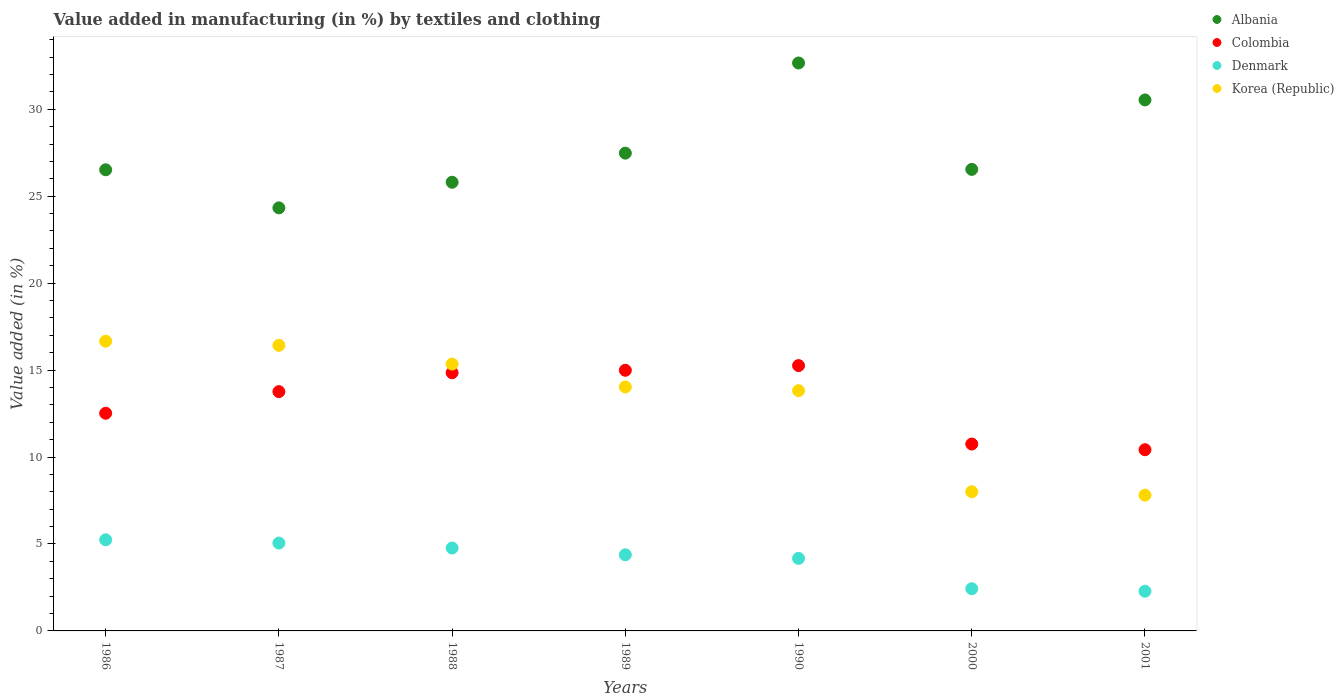How many different coloured dotlines are there?
Ensure brevity in your answer.  4. What is the percentage of value added in manufacturing by textiles and clothing in Korea (Republic) in 1990?
Provide a short and direct response. 13.82. Across all years, what is the maximum percentage of value added in manufacturing by textiles and clothing in Albania?
Your answer should be very brief. 32.66. Across all years, what is the minimum percentage of value added in manufacturing by textiles and clothing in Albania?
Ensure brevity in your answer.  24.33. In which year was the percentage of value added in manufacturing by textiles and clothing in Korea (Republic) minimum?
Make the answer very short. 2001. What is the total percentage of value added in manufacturing by textiles and clothing in Albania in the graph?
Provide a short and direct response. 193.86. What is the difference between the percentage of value added in manufacturing by textiles and clothing in Albania in 1990 and that in 2000?
Provide a short and direct response. 6.12. What is the difference between the percentage of value added in manufacturing by textiles and clothing in Denmark in 1989 and the percentage of value added in manufacturing by textiles and clothing in Albania in 1986?
Your answer should be very brief. -22.14. What is the average percentage of value added in manufacturing by textiles and clothing in Colombia per year?
Offer a terse response. 13.22. In the year 2001, what is the difference between the percentage of value added in manufacturing by textiles and clothing in Denmark and percentage of value added in manufacturing by textiles and clothing in Colombia?
Ensure brevity in your answer.  -8.14. What is the ratio of the percentage of value added in manufacturing by textiles and clothing in Denmark in 1987 to that in 1990?
Offer a very short reply. 1.21. Is the percentage of value added in manufacturing by textiles and clothing in Colombia in 1989 less than that in 2000?
Give a very brief answer. No. Is the difference between the percentage of value added in manufacturing by textiles and clothing in Denmark in 1990 and 2001 greater than the difference between the percentage of value added in manufacturing by textiles and clothing in Colombia in 1990 and 2001?
Keep it short and to the point. No. What is the difference between the highest and the second highest percentage of value added in manufacturing by textiles and clothing in Albania?
Keep it short and to the point. 2.12. What is the difference between the highest and the lowest percentage of value added in manufacturing by textiles and clothing in Denmark?
Your answer should be very brief. 2.96. In how many years, is the percentage of value added in manufacturing by textiles and clothing in Albania greater than the average percentage of value added in manufacturing by textiles and clothing in Albania taken over all years?
Your answer should be very brief. 2. Is it the case that in every year, the sum of the percentage of value added in manufacturing by textiles and clothing in Colombia and percentage of value added in manufacturing by textiles and clothing in Korea (Republic)  is greater than the sum of percentage of value added in manufacturing by textiles and clothing in Denmark and percentage of value added in manufacturing by textiles and clothing in Albania?
Keep it short and to the point. No. Does the percentage of value added in manufacturing by textiles and clothing in Albania monotonically increase over the years?
Provide a succinct answer. No. Is the percentage of value added in manufacturing by textiles and clothing in Albania strictly greater than the percentage of value added in manufacturing by textiles and clothing in Denmark over the years?
Provide a short and direct response. Yes. Is the percentage of value added in manufacturing by textiles and clothing in Colombia strictly less than the percentage of value added in manufacturing by textiles and clothing in Korea (Republic) over the years?
Provide a succinct answer. No. How many dotlines are there?
Give a very brief answer. 4. Does the graph contain any zero values?
Provide a succinct answer. No. Does the graph contain grids?
Ensure brevity in your answer.  No. How are the legend labels stacked?
Your answer should be compact. Vertical. What is the title of the graph?
Provide a succinct answer. Value added in manufacturing (in %) by textiles and clothing. What is the label or title of the Y-axis?
Your response must be concise. Value added (in %). What is the Value added (in %) of Albania in 1986?
Your answer should be compact. 26.52. What is the Value added (in %) in Colombia in 1986?
Provide a succinct answer. 12.52. What is the Value added (in %) of Denmark in 1986?
Make the answer very short. 5.24. What is the Value added (in %) in Korea (Republic) in 1986?
Your answer should be compact. 16.66. What is the Value added (in %) in Albania in 1987?
Provide a succinct answer. 24.33. What is the Value added (in %) in Colombia in 1987?
Offer a very short reply. 13.76. What is the Value added (in %) of Denmark in 1987?
Make the answer very short. 5.05. What is the Value added (in %) in Korea (Republic) in 1987?
Your answer should be compact. 16.42. What is the Value added (in %) of Albania in 1988?
Your answer should be very brief. 25.8. What is the Value added (in %) in Colombia in 1988?
Your response must be concise. 14.85. What is the Value added (in %) in Denmark in 1988?
Offer a terse response. 4.77. What is the Value added (in %) of Korea (Republic) in 1988?
Your response must be concise. 15.35. What is the Value added (in %) in Albania in 1989?
Your answer should be very brief. 27.47. What is the Value added (in %) in Colombia in 1989?
Your answer should be compact. 14.99. What is the Value added (in %) of Denmark in 1989?
Give a very brief answer. 4.38. What is the Value added (in %) in Korea (Republic) in 1989?
Your answer should be very brief. 14.03. What is the Value added (in %) of Albania in 1990?
Ensure brevity in your answer.  32.66. What is the Value added (in %) in Colombia in 1990?
Your answer should be compact. 15.26. What is the Value added (in %) of Denmark in 1990?
Make the answer very short. 4.17. What is the Value added (in %) of Korea (Republic) in 1990?
Offer a very short reply. 13.82. What is the Value added (in %) of Albania in 2000?
Ensure brevity in your answer.  26.54. What is the Value added (in %) of Colombia in 2000?
Offer a terse response. 10.75. What is the Value added (in %) of Denmark in 2000?
Keep it short and to the point. 2.43. What is the Value added (in %) in Korea (Republic) in 2000?
Make the answer very short. 8. What is the Value added (in %) of Albania in 2001?
Provide a succinct answer. 30.53. What is the Value added (in %) of Colombia in 2001?
Your answer should be compact. 10.42. What is the Value added (in %) in Denmark in 2001?
Ensure brevity in your answer.  2.28. What is the Value added (in %) in Korea (Republic) in 2001?
Your answer should be very brief. 7.81. Across all years, what is the maximum Value added (in %) in Albania?
Keep it short and to the point. 32.66. Across all years, what is the maximum Value added (in %) of Colombia?
Give a very brief answer. 15.26. Across all years, what is the maximum Value added (in %) of Denmark?
Ensure brevity in your answer.  5.24. Across all years, what is the maximum Value added (in %) in Korea (Republic)?
Your answer should be very brief. 16.66. Across all years, what is the minimum Value added (in %) of Albania?
Ensure brevity in your answer.  24.33. Across all years, what is the minimum Value added (in %) of Colombia?
Make the answer very short. 10.42. Across all years, what is the minimum Value added (in %) in Denmark?
Make the answer very short. 2.28. Across all years, what is the minimum Value added (in %) in Korea (Republic)?
Keep it short and to the point. 7.81. What is the total Value added (in %) of Albania in the graph?
Your response must be concise. 193.86. What is the total Value added (in %) of Colombia in the graph?
Ensure brevity in your answer.  92.54. What is the total Value added (in %) of Denmark in the graph?
Provide a succinct answer. 28.32. What is the total Value added (in %) in Korea (Republic) in the graph?
Give a very brief answer. 92.08. What is the difference between the Value added (in %) of Albania in 1986 and that in 1987?
Make the answer very short. 2.19. What is the difference between the Value added (in %) in Colombia in 1986 and that in 1987?
Offer a terse response. -1.24. What is the difference between the Value added (in %) of Denmark in 1986 and that in 1987?
Provide a succinct answer. 0.19. What is the difference between the Value added (in %) in Korea (Republic) in 1986 and that in 1987?
Provide a short and direct response. 0.24. What is the difference between the Value added (in %) of Albania in 1986 and that in 1988?
Offer a very short reply. 0.72. What is the difference between the Value added (in %) in Colombia in 1986 and that in 1988?
Make the answer very short. -2.33. What is the difference between the Value added (in %) in Denmark in 1986 and that in 1988?
Provide a succinct answer. 0.47. What is the difference between the Value added (in %) in Korea (Republic) in 1986 and that in 1988?
Make the answer very short. 1.31. What is the difference between the Value added (in %) in Albania in 1986 and that in 1989?
Your answer should be compact. -0.96. What is the difference between the Value added (in %) of Colombia in 1986 and that in 1989?
Your answer should be compact. -2.47. What is the difference between the Value added (in %) in Denmark in 1986 and that in 1989?
Provide a succinct answer. 0.86. What is the difference between the Value added (in %) of Korea (Republic) in 1986 and that in 1989?
Give a very brief answer. 2.63. What is the difference between the Value added (in %) of Albania in 1986 and that in 1990?
Ensure brevity in your answer.  -6.14. What is the difference between the Value added (in %) in Colombia in 1986 and that in 1990?
Keep it short and to the point. -2.74. What is the difference between the Value added (in %) in Denmark in 1986 and that in 1990?
Your response must be concise. 1.07. What is the difference between the Value added (in %) of Korea (Republic) in 1986 and that in 1990?
Keep it short and to the point. 2.84. What is the difference between the Value added (in %) in Albania in 1986 and that in 2000?
Keep it short and to the point. -0.02. What is the difference between the Value added (in %) in Colombia in 1986 and that in 2000?
Offer a terse response. 1.77. What is the difference between the Value added (in %) of Denmark in 1986 and that in 2000?
Provide a short and direct response. 2.81. What is the difference between the Value added (in %) of Korea (Republic) in 1986 and that in 2000?
Your answer should be very brief. 8.66. What is the difference between the Value added (in %) of Albania in 1986 and that in 2001?
Give a very brief answer. -4.02. What is the difference between the Value added (in %) of Colombia in 1986 and that in 2001?
Ensure brevity in your answer.  2.1. What is the difference between the Value added (in %) in Denmark in 1986 and that in 2001?
Keep it short and to the point. 2.96. What is the difference between the Value added (in %) of Korea (Republic) in 1986 and that in 2001?
Keep it short and to the point. 8.85. What is the difference between the Value added (in %) in Albania in 1987 and that in 1988?
Provide a succinct answer. -1.47. What is the difference between the Value added (in %) in Colombia in 1987 and that in 1988?
Keep it short and to the point. -1.09. What is the difference between the Value added (in %) in Denmark in 1987 and that in 1988?
Give a very brief answer. 0.28. What is the difference between the Value added (in %) in Korea (Republic) in 1987 and that in 1988?
Your answer should be very brief. 1.08. What is the difference between the Value added (in %) of Albania in 1987 and that in 1989?
Provide a succinct answer. -3.15. What is the difference between the Value added (in %) of Colombia in 1987 and that in 1989?
Offer a very short reply. -1.23. What is the difference between the Value added (in %) of Denmark in 1987 and that in 1989?
Give a very brief answer. 0.68. What is the difference between the Value added (in %) of Korea (Republic) in 1987 and that in 1989?
Provide a succinct answer. 2.39. What is the difference between the Value added (in %) of Albania in 1987 and that in 1990?
Offer a terse response. -8.33. What is the difference between the Value added (in %) of Colombia in 1987 and that in 1990?
Provide a succinct answer. -1.5. What is the difference between the Value added (in %) of Denmark in 1987 and that in 1990?
Provide a short and direct response. 0.88. What is the difference between the Value added (in %) in Korea (Republic) in 1987 and that in 1990?
Provide a short and direct response. 2.61. What is the difference between the Value added (in %) of Albania in 1987 and that in 2000?
Your response must be concise. -2.21. What is the difference between the Value added (in %) in Colombia in 1987 and that in 2000?
Your answer should be very brief. 3.01. What is the difference between the Value added (in %) of Denmark in 1987 and that in 2000?
Your response must be concise. 2.62. What is the difference between the Value added (in %) in Korea (Republic) in 1987 and that in 2000?
Give a very brief answer. 8.42. What is the difference between the Value added (in %) of Albania in 1987 and that in 2001?
Your answer should be very brief. -6.21. What is the difference between the Value added (in %) of Colombia in 1987 and that in 2001?
Provide a succinct answer. 3.34. What is the difference between the Value added (in %) in Denmark in 1987 and that in 2001?
Provide a short and direct response. 2.77. What is the difference between the Value added (in %) in Korea (Republic) in 1987 and that in 2001?
Ensure brevity in your answer.  8.61. What is the difference between the Value added (in %) in Albania in 1988 and that in 1989?
Offer a very short reply. -1.67. What is the difference between the Value added (in %) in Colombia in 1988 and that in 1989?
Offer a terse response. -0.14. What is the difference between the Value added (in %) of Denmark in 1988 and that in 1989?
Keep it short and to the point. 0.39. What is the difference between the Value added (in %) of Korea (Republic) in 1988 and that in 1989?
Your answer should be compact. 1.32. What is the difference between the Value added (in %) in Albania in 1988 and that in 1990?
Your answer should be compact. -6.86. What is the difference between the Value added (in %) in Colombia in 1988 and that in 1990?
Make the answer very short. -0.41. What is the difference between the Value added (in %) of Denmark in 1988 and that in 1990?
Provide a short and direct response. 0.6. What is the difference between the Value added (in %) in Korea (Republic) in 1988 and that in 1990?
Ensure brevity in your answer.  1.53. What is the difference between the Value added (in %) of Albania in 1988 and that in 2000?
Make the answer very short. -0.74. What is the difference between the Value added (in %) in Colombia in 1988 and that in 2000?
Provide a short and direct response. 4.1. What is the difference between the Value added (in %) in Denmark in 1988 and that in 2000?
Your answer should be very brief. 2.34. What is the difference between the Value added (in %) of Korea (Republic) in 1988 and that in 2000?
Provide a succinct answer. 7.34. What is the difference between the Value added (in %) of Albania in 1988 and that in 2001?
Give a very brief answer. -4.73. What is the difference between the Value added (in %) of Colombia in 1988 and that in 2001?
Your answer should be compact. 4.43. What is the difference between the Value added (in %) of Denmark in 1988 and that in 2001?
Give a very brief answer. 2.49. What is the difference between the Value added (in %) of Korea (Republic) in 1988 and that in 2001?
Provide a short and direct response. 7.54. What is the difference between the Value added (in %) of Albania in 1989 and that in 1990?
Make the answer very short. -5.18. What is the difference between the Value added (in %) of Colombia in 1989 and that in 1990?
Keep it short and to the point. -0.27. What is the difference between the Value added (in %) of Denmark in 1989 and that in 1990?
Your answer should be compact. 0.21. What is the difference between the Value added (in %) in Korea (Republic) in 1989 and that in 1990?
Offer a very short reply. 0.21. What is the difference between the Value added (in %) in Albania in 1989 and that in 2000?
Offer a very short reply. 0.93. What is the difference between the Value added (in %) of Colombia in 1989 and that in 2000?
Give a very brief answer. 4.24. What is the difference between the Value added (in %) in Denmark in 1989 and that in 2000?
Ensure brevity in your answer.  1.95. What is the difference between the Value added (in %) in Korea (Republic) in 1989 and that in 2000?
Provide a succinct answer. 6.03. What is the difference between the Value added (in %) in Albania in 1989 and that in 2001?
Your response must be concise. -3.06. What is the difference between the Value added (in %) in Colombia in 1989 and that in 2001?
Your answer should be compact. 4.57. What is the difference between the Value added (in %) in Denmark in 1989 and that in 2001?
Your response must be concise. 2.09. What is the difference between the Value added (in %) in Korea (Republic) in 1989 and that in 2001?
Your answer should be compact. 6.22. What is the difference between the Value added (in %) of Albania in 1990 and that in 2000?
Your response must be concise. 6.12. What is the difference between the Value added (in %) in Colombia in 1990 and that in 2000?
Offer a very short reply. 4.51. What is the difference between the Value added (in %) in Denmark in 1990 and that in 2000?
Keep it short and to the point. 1.74. What is the difference between the Value added (in %) of Korea (Republic) in 1990 and that in 2000?
Make the answer very short. 5.81. What is the difference between the Value added (in %) in Albania in 1990 and that in 2001?
Your answer should be compact. 2.12. What is the difference between the Value added (in %) of Colombia in 1990 and that in 2001?
Provide a short and direct response. 4.84. What is the difference between the Value added (in %) of Denmark in 1990 and that in 2001?
Provide a short and direct response. 1.89. What is the difference between the Value added (in %) in Korea (Republic) in 1990 and that in 2001?
Your answer should be very brief. 6.01. What is the difference between the Value added (in %) in Albania in 2000 and that in 2001?
Provide a succinct answer. -3.99. What is the difference between the Value added (in %) in Colombia in 2000 and that in 2001?
Your answer should be very brief. 0.33. What is the difference between the Value added (in %) of Denmark in 2000 and that in 2001?
Offer a terse response. 0.15. What is the difference between the Value added (in %) of Korea (Republic) in 2000 and that in 2001?
Make the answer very short. 0.2. What is the difference between the Value added (in %) of Albania in 1986 and the Value added (in %) of Colombia in 1987?
Offer a terse response. 12.76. What is the difference between the Value added (in %) of Albania in 1986 and the Value added (in %) of Denmark in 1987?
Your answer should be very brief. 21.47. What is the difference between the Value added (in %) of Albania in 1986 and the Value added (in %) of Korea (Republic) in 1987?
Make the answer very short. 10.1. What is the difference between the Value added (in %) of Colombia in 1986 and the Value added (in %) of Denmark in 1987?
Ensure brevity in your answer.  7.46. What is the difference between the Value added (in %) of Colombia in 1986 and the Value added (in %) of Korea (Republic) in 1987?
Your response must be concise. -3.9. What is the difference between the Value added (in %) in Denmark in 1986 and the Value added (in %) in Korea (Republic) in 1987?
Keep it short and to the point. -11.18. What is the difference between the Value added (in %) in Albania in 1986 and the Value added (in %) in Colombia in 1988?
Provide a short and direct response. 11.67. What is the difference between the Value added (in %) of Albania in 1986 and the Value added (in %) of Denmark in 1988?
Make the answer very short. 21.75. What is the difference between the Value added (in %) in Albania in 1986 and the Value added (in %) in Korea (Republic) in 1988?
Ensure brevity in your answer.  11.17. What is the difference between the Value added (in %) of Colombia in 1986 and the Value added (in %) of Denmark in 1988?
Provide a short and direct response. 7.75. What is the difference between the Value added (in %) in Colombia in 1986 and the Value added (in %) in Korea (Republic) in 1988?
Make the answer very short. -2.83. What is the difference between the Value added (in %) in Denmark in 1986 and the Value added (in %) in Korea (Republic) in 1988?
Keep it short and to the point. -10.11. What is the difference between the Value added (in %) of Albania in 1986 and the Value added (in %) of Colombia in 1989?
Give a very brief answer. 11.53. What is the difference between the Value added (in %) of Albania in 1986 and the Value added (in %) of Denmark in 1989?
Provide a short and direct response. 22.14. What is the difference between the Value added (in %) of Albania in 1986 and the Value added (in %) of Korea (Republic) in 1989?
Provide a succinct answer. 12.49. What is the difference between the Value added (in %) of Colombia in 1986 and the Value added (in %) of Denmark in 1989?
Provide a short and direct response. 8.14. What is the difference between the Value added (in %) of Colombia in 1986 and the Value added (in %) of Korea (Republic) in 1989?
Your answer should be compact. -1.51. What is the difference between the Value added (in %) in Denmark in 1986 and the Value added (in %) in Korea (Republic) in 1989?
Make the answer very short. -8.79. What is the difference between the Value added (in %) of Albania in 1986 and the Value added (in %) of Colombia in 1990?
Your response must be concise. 11.26. What is the difference between the Value added (in %) in Albania in 1986 and the Value added (in %) in Denmark in 1990?
Give a very brief answer. 22.35. What is the difference between the Value added (in %) in Albania in 1986 and the Value added (in %) in Korea (Republic) in 1990?
Make the answer very short. 12.7. What is the difference between the Value added (in %) of Colombia in 1986 and the Value added (in %) of Denmark in 1990?
Ensure brevity in your answer.  8.35. What is the difference between the Value added (in %) in Colombia in 1986 and the Value added (in %) in Korea (Republic) in 1990?
Your answer should be compact. -1.3. What is the difference between the Value added (in %) of Denmark in 1986 and the Value added (in %) of Korea (Republic) in 1990?
Offer a terse response. -8.58. What is the difference between the Value added (in %) in Albania in 1986 and the Value added (in %) in Colombia in 2000?
Provide a succinct answer. 15.77. What is the difference between the Value added (in %) of Albania in 1986 and the Value added (in %) of Denmark in 2000?
Offer a terse response. 24.09. What is the difference between the Value added (in %) of Albania in 1986 and the Value added (in %) of Korea (Republic) in 2000?
Give a very brief answer. 18.51. What is the difference between the Value added (in %) of Colombia in 1986 and the Value added (in %) of Denmark in 2000?
Provide a succinct answer. 10.09. What is the difference between the Value added (in %) in Colombia in 1986 and the Value added (in %) in Korea (Republic) in 2000?
Provide a succinct answer. 4.51. What is the difference between the Value added (in %) in Denmark in 1986 and the Value added (in %) in Korea (Republic) in 2000?
Your response must be concise. -2.76. What is the difference between the Value added (in %) of Albania in 1986 and the Value added (in %) of Colombia in 2001?
Provide a succinct answer. 16.1. What is the difference between the Value added (in %) in Albania in 1986 and the Value added (in %) in Denmark in 2001?
Your answer should be compact. 24.24. What is the difference between the Value added (in %) in Albania in 1986 and the Value added (in %) in Korea (Republic) in 2001?
Provide a succinct answer. 18.71. What is the difference between the Value added (in %) of Colombia in 1986 and the Value added (in %) of Denmark in 2001?
Give a very brief answer. 10.23. What is the difference between the Value added (in %) in Colombia in 1986 and the Value added (in %) in Korea (Republic) in 2001?
Provide a short and direct response. 4.71. What is the difference between the Value added (in %) of Denmark in 1986 and the Value added (in %) of Korea (Republic) in 2001?
Give a very brief answer. -2.57. What is the difference between the Value added (in %) of Albania in 1987 and the Value added (in %) of Colombia in 1988?
Give a very brief answer. 9.48. What is the difference between the Value added (in %) in Albania in 1987 and the Value added (in %) in Denmark in 1988?
Your response must be concise. 19.56. What is the difference between the Value added (in %) of Albania in 1987 and the Value added (in %) of Korea (Republic) in 1988?
Provide a short and direct response. 8.98. What is the difference between the Value added (in %) of Colombia in 1987 and the Value added (in %) of Denmark in 1988?
Keep it short and to the point. 8.99. What is the difference between the Value added (in %) of Colombia in 1987 and the Value added (in %) of Korea (Republic) in 1988?
Provide a short and direct response. -1.59. What is the difference between the Value added (in %) in Denmark in 1987 and the Value added (in %) in Korea (Republic) in 1988?
Keep it short and to the point. -10.29. What is the difference between the Value added (in %) of Albania in 1987 and the Value added (in %) of Colombia in 1989?
Ensure brevity in your answer.  9.34. What is the difference between the Value added (in %) of Albania in 1987 and the Value added (in %) of Denmark in 1989?
Provide a short and direct response. 19.95. What is the difference between the Value added (in %) in Albania in 1987 and the Value added (in %) in Korea (Republic) in 1989?
Your response must be concise. 10.3. What is the difference between the Value added (in %) of Colombia in 1987 and the Value added (in %) of Denmark in 1989?
Make the answer very short. 9.38. What is the difference between the Value added (in %) in Colombia in 1987 and the Value added (in %) in Korea (Republic) in 1989?
Ensure brevity in your answer.  -0.27. What is the difference between the Value added (in %) of Denmark in 1987 and the Value added (in %) of Korea (Republic) in 1989?
Provide a short and direct response. -8.98. What is the difference between the Value added (in %) in Albania in 1987 and the Value added (in %) in Colombia in 1990?
Your answer should be compact. 9.07. What is the difference between the Value added (in %) of Albania in 1987 and the Value added (in %) of Denmark in 1990?
Keep it short and to the point. 20.16. What is the difference between the Value added (in %) of Albania in 1987 and the Value added (in %) of Korea (Republic) in 1990?
Give a very brief answer. 10.51. What is the difference between the Value added (in %) in Colombia in 1987 and the Value added (in %) in Denmark in 1990?
Make the answer very short. 9.59. What is the difference between the Value added (in %) in Colombia in 1987 and the Value added (in %) in Korea (Republic) in 1990?
Keep it short and to the point. -0.06. What is the difference between the Value added (in %) of Denmark in 1987 and the Value added (in %) of Korea (Republic) in 1990?
Make the answer very short. -8.76. What is the difference between the Value added (in %) in Albania in 1987 and the Value added (in %) in Colombia in 2000?
Give a very brief answer. 13.58. What is the difference between the Value added (in %) in Albania in 1987 and the Value added (in %) in Denmark in 2000?
Ensure brevity in your answer.  21.9. What is the difference between the Value added (in %) of Albania in 1987 and the Value added (in %) of Korea (Republic) in 2000?
Your answer should be very brief. 16.33. What is the difference between the Value added (in %) in Colombia in 1987 and the Value added (in %) in Denmark in 2000?
Provide a succinct answer. 11.33. What is the difference between the Value added (in %) in Colombia in 1987 and the Value added (in %) in Korea (Republic) in 2000?
Keep it short and to the point. 5.76. What is the difference between the Value added (in %) of Denmark in 1987 and the Value added (in %) of Korea (Republic) in 2000?
Offer a very short reply. -2.95. What is the difference between the Value added (in %) in Albania in 1987 and the Value added (in %) in Colombia in 2001?
Give a very brief answer. 13.91. What is the difference between the Value added (in %) of Albania in 1987 and the Value added (in %) of Denmark in 2001?
Your response must be concise. 22.05. What is the difference between the Value added (in %) in Albania in 1987 and the Value added (in %) in Korea (Republic) in 2001?
Offer a very short reply. 16.52. What is the difference between the Value added (in %) in Colombia in 1987 and the Value added (in %) in Denmark in 2001?
Provide a succinct answer. 11.48. What is the difference between the Value added (in %) of Colombia in 1987 and the Value added (in %) of Korea (Republic) in 2001?
Provide a short and direct response. 5.95. What is the difference between the Value added (in %) in Denmark in 1987 and the Value added (in %) in Korea (Republic) in 2001?
Make the answer very short. -2.76. What is the difference between the Value added (in %) of Albania in 1988 and the Value added (in %) of Colombia in 1989?
Provide a short and direct response. 10.81. What is the difference between the Value added (in %) of Albania in 1988 and the Value added (in %) of Denmark in 1989?
Provide a short and direct response. 21.42. What is the difference between the Value added (in %) of Albania in 1988 and the Value added (in %) of Korea (Republic) in 1989?
Your answer should be very brief. 11.77. What is the difference between the Value added (in %) of Colombia in 1988 and the Value added (in %) of Denmark in 1989?
Ensure brevity in your answer.  10.47. What is the difference between the Value added (in %) in Colombia in 1988 and the Value added (in %) in Korea (Republic) in 1989?
Offer a very short reply. 0.82. What is the difference between the Value added (in %) of Denmark in 1988 and the Value added (in %) of Korea (Republic) in 1989?
Provide a succinct answer. -9.26. What is the difference between the Value added (in %) in Albania in 1988 and the Value added (in %) in Colombia in 1990?
Your answer should be compact. 10.54. What is the difference between the Value added (in %) in Albania in 1988 and the Value added (in %) in Denmark in 1990?
Your response must be concise. 21.63. What is the difference between the Value added (in %) of Albania in 1988 and the Value added (in %) of Korea (Republic) in 1990?
Keep it short and to the point. 11.99. What is the difference between the Value added (in %) of Colombia in 1988 and the Value added (in %) of Denmark in 1990?
Your answer should be compact. 10.68. What is the difference between the Value added (in %) of Colombia in 1988 and the Value added (in %) of Korea (Republic) in 1990?
Your response must be concise. 1.03. What is the difference between the Value added (in %) in Denmark in 1988 and the Value added (in %) in Korea (Republic) in 1990?
Your answer should be very brief. -9.05. What is the difference between the Value added (in %) in Albania in 1988 and the Value added (in %) in Colombia in 2000?
Your answer should be very brief. 15.05. What is the difference between the Value added (in %) in Albania in 1988 and the Value added (in %) in Denmark in 2000?
Your answer should be compact. 23.37. What is the difference between the Value added (in %) in Albania in 1988 and the Value added (in %) in Korea (Republic) in 2000?
Offer a very short reply. 17.8. What is the difference between the Value added (in %) of Colombia in 1988 and the Value added (in %) of Denmark in 2000?
Provide a succinct answer. 12.42. What is the difference between the Value added (in %) in Colombia in 1988 and the Value added (in %) in Korea (Republic) in 2000?
Provide a succinct answer. 6.84. What is the difference between the Value added (in %) of Denmark in 1988 and the Value added (in %) of Korea (Republic) in 2000?
Make the answer very short. -3.24. What is the difference between the Value added (in %) of Albania in 1988 and the Value added (in %) of Colombia in 2001?
Make the answer very short. 15.38. What is the difference between the Value added (in %) of Albania in 1988 and the Value added (in %) of Denmark in 2001?
Offer a terse response. 23.52. What is the difference between the Value added (in %) in Albania in 1988 and the Value added (in %) in Korea (Republic) in 2001?
Your answer should be very brief. 17.99. What is the difference between the Value added (in %) of Colombia in 1988 and the Value added (in %) of Denmark in 2001?
Your answer should be very brief. 12.56. What is the difference between the Value added (in %) of Colombia in 1988 and the Value added (in %) of Korea (Republic) in 2001?
Your response must be concise. 7.04. What is the difference between the Value added (in %) in Denmark in 1988 and the Value added (in %) in Korea (Republic) in 2001?
Ensure brevity in your answer.  -3.04. What is the difference between the Value added (in %) in Albania in 1989 and the Value added (in %) in Colombia in 1990?
Offer a very short reply. 12.22. What is the difference between the Value added (in %) in Albania in 1989 and the Value added (in %) in Denmark in 1990?
Make the answer very short. 23.3. What is the difference between the Value added (in %) in Albania in 1989 and the Value added (in %) in Korea (Republic) in 1990?
Your answer should be very brief. 13.66. What is the difference between the Value added (in %) in Colombia in 1989 and the Value added (in %) in Denmark in 1990?
Keep it short and to the point. 10.82. What is the difference between the Value added (in %) of Colombia in 1989 and the Value added (in %) of Korea (Republic) in 1990?
Make the answer very short. 1.17. What is the difference between the Value added (in %) in Denmark in 1989 and the Value added (in %) in Korea (Republic) in 1990?
Provide a succinct answer. -9.44. What is the difference between the Value added (in %) in Albania in 1989 and the Value added (in %) in Colombia in 2000?
Provide a succinct answer. 16.73. What is the difference between the Value added (in %) in Albania in 1989 and the Value added (in %) in Denmark in 2000?
Provide a short and direct response. 25.05. What is the difference between the Value added (in %) of Albania in 1989 and the Value added (in %) of Korea (Republic) in 2000?
Offer a terse response. 19.47. What is the difference between the Value added (in %) in Colombia in 1989 and the Value added (in %) in Denmark in 2000?
Your answer should be very brief. 12.56. What is the difference between the Value added (in %) of Colombia in 1989 and the Value added (in %) of Korea (Republic) in 2000?
Give a very brief answer. 6.98. What is the difference between the Value added (in %) of Denmark in 1989 and the Value added (in %) of Korea (Republic) in 2000?
Your answer should be very brief. -3.63. What is the difference between the Value added (in %) of Albania in 1989 and the Value added (in %) of Colombia in 2001?
Give a very brief answer. 17.05. What is the difference between the Value added (in %) in Albania in 1989 and the Value added (in %) in Denmark in 2001?
Provide a short and direct response. 25.19. What is the difference between the Value added (in %) in Albania in 1989 and the Value added (in %) in Korea (Republic) in 2001?
Your answer should be very brief. 19.67. What is the difference between the Value added (in %) of Colombia in 1989 and the Value added (in %) of Denmark in 2001?
Offer a very short reply. 12.71. What is the difference between the Value added (in %) of Colombia in 1989 and the Value added (in %) of Korea (Republic) in 2001?
Ensure brevity in your answer.  7.18. What is the difference between the Value added (in %) of Denmark in 1989 and the Value added (in %) of Korea (Republic) in 2001?
Offer a terse response. -3.43. What is the difference between the Value added (in %) in Albania in 1990 and the Value added (in %) in Colombia in 2000?
Give a very brief answer. 21.91. What is the difference between the Value added (in %) of Albania in 1990 and the Value added (in %) of Denmark in 2000?
Provide a short and direct response. 30.23. What is the difference between the Value added (in %) of Albania in 1990 and the Value added (in %) of Korea (Republic) in 2000?
Make the answer very short. 24.66. What is the difference between the Value added (in %) in Colombia in 1990 and the Value added (in %) in Denmark in 2000?
Your response must be concise. 12.83. What is the difference between the Value added (in %) in Colombia in 1990 and the Value added (in %) in Korea (Republic) in 2000?
Your answer should be compact. 7.25. What is the difference between the Value added (in %) in Denmark in 1990 and the Value added (in %) in Korea (Republic) in 2000?
Ensure brevity in your answer.  -3.83. What is the difference between the Value added (in %) of Albania in 1990 and the Value added (in %) of Colombia in 2001?
Offer a very short reply. 22.24. What is the difference between the Value added (in %) of Albania in 1990 and the Value added (in %) of Denmark in 2001?
Ensure brevity in your answer.  30.38. What is the difference between the Value added (in %) in Albania in 1990 and the Value added (in %) in Korea (Republic) in 2001?
Your answer should be very brief. 24.85. What is the difference between the Value added (in %) in Colombia in 1990 and the Value added (in %) in Denmark in 2001?
Provide a succinct answer. 12.98. What is the difference between the Value added (in %) in Colombia in 1990 and the Value added (in %) in Korea (Republic) in 2001?
Provide a succinct answer. 7.45. What is the difference between the Value added (in %) in Denmark in 1990 and the Value added (in %) in Korea (Republic) in 2001?
Your answer should be compact. -3.64. What is the difference between the Value added (in %) in Albania in 2000 and the Value added (in %) in Colombia in 2001?
Your response must be concise. 16.12. What is the difference between the Value added (in %) of Albania in 2000 and the Value added (in %) of Denmark in 2001?
Your response must be concise. 24.26. What is the difference between the Value added (in %) of Albania in 2000 and the Value added (in %) of Korea (Republic) in 2001?
Provide a short and direct response. 18.73. What is the difference between the Value added (in %) of Colombia in 2000 and the Value added (in %) of Denmark in 2001?
Provide a short and direct response. 8.46. What is the difference between the Value added (in %) in Colombia in 2000 and the Value added (in %) in Korea (Republic) in 2001?
Provide a short and direct response. 2.94. What is the difference between the Value added (in %) of Denmark in 2000 and the Value added (in %) of Korea (Republic) in 2001?
Your response must be concise. -5.38. What is the average Value added (in %) in Albania per year?
Make the answer very short. 27.69. What is the average Value added (in %) in Colombia per year?
Provide a succinct answer. 13.22. What is the average Value added (in %) of Denmark per year?
Your answer should be very brief. 4.05. What is the average Value added (in %) in Korea (Republic) per year?
Give a very brief answer. 13.15. In the year 1986, what is the difference between the Value added (in %) of Albania and Value added (in %) of Colombia?
Offer a terse response. 14. In the year 1986, what is the difference between the Value added (in %) in Albania and Value added (in %) in Denmark?
Provide a short and direct response. 21.28. In the year 1986, what is the difference between the Value added (in %) in Albania and Value added (in %) in Korea (Republic)?
Offer a terse response. 9.86. In the year 1986, what is the difference between the Value added (in %) in Colombia and Value added (in %) in Denmark?
Give a very brief answer. 7.28. In the year 1986, what is the difference between the Value added (in %) in Colombia and Value added (in %) in Korea (Republic)?
Offer a very short reply. -4.14. In the year 1986, what is the difference between the Value added (in %) in Denmark and Value added (in %) in Korea (Republic)?
Give a very brief answer. -11.42. In the year 1987, what is the difference between the Value added (in %) of Albania and Value added (in %) of Colombia?
Your answer should be compact. 10.57. In the year 1987, what is the difference between the Value added (in %) of Albania and Value added (in %) of Denmark?
Your answer should be compact. 19.28. In the year 1987, what is the difference between the Value added (in %) of Albania and Value added (in %) of Korea (Republic)?
Offer a terse response. 7.91. In the year 1987, what is the difference between the Value added (in %) in Colombia and Value added (in %) in Denmark?
Provide a succinct answer. 8.71. In the year 1987, what is the difference between the Value added (in %) in Colombia and Value added (in %) in Korea (Republic)?
Your answer should be very brief. -2.66. In the year 1987, what is the difference between the Value added (in %) of Denmark and Value added (in %) of Korea (Republic)?
Your answer should be very brief. -11.37. In the year 1988, what is the difference between the Value added (in %) of Albania and Value added (in %) of Colombia?
Ensure brevity in your answer.  10.95. In the year 1988, what is the difference between the Value added (in %) of Albania and Value added (in %) of Denmark?
Offer a very short reply. 21.03. In the year 1988, what is the difference between the Value added (in %) in Albania and Value added (in %) in Korea (Republic)?
Keep it short and to the point. 10.46. In the year 1988, what is the difference between the Value added (in %) of Colombia and Value added (in %) of Denmark?
Keep it short and to the point. 10.08. In the year 1988, what is the difference between the Value added (in %) of Colombia and Value added (in %) of Korea (Republic)?
Your response must be concise. -0.5. In the year 1988, what is the difference between the Value added (in %) of Denmark and Value added (in %) of Korea (Republic)?
Your answer should be very brief. -10.58. In the year 1989, what is the difference between the Value added (in %) of Albania and Value added (in %) of Colombia?
Your response must be concise. 12.49. In the year 1989, what is the difference between the Value added (in %) in Albania and Value added (in %) in Denmark?
Your answer should be very brief. 23.1. In the year 1989, what is the difference between the Value added (in %) in Albania and Value added (in %) in Korea (Republic)?
Provide a short and direct response. 13.45. In the year 1989, what is the difference between the Value added (in %) in Colombia and Value added (in %) in Denmark?
Ensure brevity in your answer.  10.61. In the year 1989, what is the difference between the Value added (in %) of Colombia and Value added (in %) of Korea (Republic)?
Your answer should be very brief. 0.96. In the year 1989, what is the difference between the Value added (in %) in Denmark and Value added (in %) in Korea (Republic)?
Your answer should be compact. -9.65. In the year 1990, what is the difference between the Value added (in %) in Albania and Value added (in %) in Colombia?
Make the answer very short. 17.4. In the year 1990, what is the difference between the Value added (in %) in Albania and Value added (in %) in Denmark?
Give a very brief answer. 28.49. In the year 1990, what is the difference between the Value added (in %) in Albania and Value added (in %) in Korea (Republic)?
Your response must be concise. 18.84. In the year 1990, what is the difference between the Value added (in %) in Colombia and Value added (in %) in Denmark?
Make the answer very short. 11.09. In the year 1990, what is the difference between the Value added (in %) of Colombia and Value added (in %) of Korea (Republic)?
Your answer should be very brief. 1.44. In the year 1990, what is the difference between the Value added (in %) in Denmark and Value added (in %) in Korea (Republic)?
Your response must be concise. -9.64. In the year 2000, what is the difference between the Value added (in %) of Albania and Value added (in %) of Colombia?
Give a very brief answer. 15.79. In the year 2000, what is the difference between the Value added (in %) of Albania and Value added (in %) of Denmark?
Make the answer very short. 24.11. In the year 2000, what is the difference between the Value added (in %) in Albania and Value added (in %) in Korea (Republic)?
Your answer should be very brief. 18.54. In the year 2000, what is the difference between the Value added (in %) of Colombia and Value added (in %) of Denmark?
Your answer should be very brief. 8.32. In the year 2000, what is the difference between the Value added (in %) of Colombia and Value added (in %) of Korea (Republic)?
Offer a terse response. 2.74. In the year 2000, what is the difference between the Value added (in %) in Denmark and Value added (in %) in Korea (Republic)?
Give a very brief answer. -5.58. In the year 2001, what is the difference between the Value added (in %) in Albania and Value added (in %) in Colombia?
Make the answer very short. 20.11. In the year 2001, what is the difference between the Value added (in %) in Albania and Value added (in %) in Denmark?
Give a very brief answer. 28.25. In the year 2001, what is the difference between the Value added (in %) in Albania and Value added (in %) in Korea (Republic)?
Make the answer very short. 22.73. In the year 2001, what is the difference between the Value added (in %) of Colombia and Value added (in %) of Denmark?
Keep it short and to the point. 8.14. In the year 2001, what is the difference between the Value added (in %) of Colombia and Value added (in %) of Korea (Republic)?
Provide a succinct answer. 2.61. In the year 2001, what is the difference between the Value added (in %) of Denmark and Value added (in %) of Korea (Republic)?
Offer a very short reply. -5.53. What is the ratio of the Value added (in %) of Albania in 1986 to that in 1987?
Your answer should be very brief. 1.09. What is the ratio of the Value added (in %) in Colombia in 1986 to that in 1987?
Provide a short and direct response. 0.91. What is the ratio of the Value added (in %) of Denmark in 1986 to that in 1987?
Your response must be concise. 1.04. What is the ratio of the Value added (in %) of Korea (Republic) in 1986 to that in 1987?
Offer a very short reply. 1.01. What is the ratio of the Value added (in %) in Albania in 1986 to that in 1988?
Keep it short and to the point. 1.03. What is the ratio of the Value added (in %) in Colombia in 1986 to that in 1988?
Your answer should be compact. 0.84. What is the ratio of the Value added (in %) of Denmark in 1986 to that in 1988?
Provide a short and direct response. 1.1. What is the ratio of the Value added (in %) of Korea (Republic) in 1986 to that in 1988?
Offer a very short reply. 1.09. What is the ratio of the Value added (in %) in Albania in 1986 to that in 1989?
Your answer should be very brief. 0.97. What is the ratio of the Value added (in %) in Colombia in 1986 to that in 1989?
Your answer should be very brief. 0.84. What is the ratio of the Value added (in %) in Denmark in 1986 to that in 1989?
Provide a succinct answer. 1.2. What is the ratio of the Value added (in %) of Korea (Republic) in 1986 to that in 1989?
Offer a very short reply. 1.19. What is the ratio of the Value added (in %) in Albania in 1986 to that in 1990?
Give a very brief answer. 0.81. What is the ratio of the Value added (in %) in Colombia in 1986 to that in 1990?
Ensure brevity in your answer.  0.82. What is the ratio of the Value added (in %) in Denmark in 1986 to that in 1990?
Ensure brevity in your answer.  1.26. What is the ratio of the Value added (in %) in Korea (Republic) in 1986 to that in 1990?
Offer a terse response. 1.21. What is the ratio of the Value added (in %) of Colombia in 1986 to that in 2000?
Ensure brevity in your answer.  1.16. What is the ratio of the Value added (in %) of Denmark in 1986 to that in 2000?
Provide a short and direct response. 2.16. What is the ratio of the Value added (in %) of Korea (Republic) in 1986 to that in 2000?
Your response must be concise. 2.08. What is the ratio of the Value added (in %) in Albania in 1986 to that in 2001?
Keep it short and to the point. 0.87. What is the ratio of the Value added (in %) in Colombia in 1986 to that in 2001?
Give a very brief answer. 1.2. What is the ratio of the Value added (in %) in Denmark in 1986 to that in 2001?
Provide a succinct answer. 2.3. What is the ratio of the Value added (in %) of Korea (Republic) in 1986 to that in 2001?
Make the answer very short. 2.13. What is the ratio of the Value added (in %) in Albania in 1987 to that in 1988?
Make the answer very short. 0.94. What is the ratio of the Value added (in %) of Colombia in 1987 to that in 1988?
Make the answer very short. 0.93. What is the ratio of the Value added (in %) of Denmark in 1987 to that in 1988?
Offer a very short reply. 1.06. What is the ratio of the Value added (in %) in Korea (Republic) in 1987 to that in 1988?
Keep it short and to the point. 1.07. What is the ratio of the Value added (in %) in Albania in 1987 to that in 1989?
Your response must be concise. 0.89. What is the ratio of the Value added (in %) in Colombia in 1987 to that in 1989?
Your response must be concise. 0.92. What is the ratio of the Value added (in %) in Denmark in 1987 to that in 1989?
Offer a terse response. 1.15. What is the ratio of the Value added (in %) in Korea (Republic) in 1987 to that in 1989?
Give a very brief answer. 1.17. What is the ratio of the Value added (in %) in Albania in 1987 to that in 1990?
Offer a very short reply. 0.74. What is the ratio of the Value added (in %) in Colombia in 1987 to that in 1990?
Offer a terse response. 0.9. What is the ratio of the Value added (in %) in Denmark in 1987 to that in 1990?
Provide a succinct answer. 1.21. What is the ratio of the Value added (in %) in Korea (Republic) in 1987 to that in 1990?
Your response must be concise. 1.19. What is the ratio of the Value added (in %) of Colombia in 1987 to that in 2000?
Give a very brief answer. 1.28. What is the ratio of the Value added (in %) of Denmark in 1987 to that in 2000?
Your answer should be very brief. 2.08. What is the ratio of the Value added (in %) of Korea (Republic) in 1987 to that in 2000?
Offer a very short reply. 2.05. What is the ratio of the Value added (in %) in Albania in 1987 to that in 2001?
Give a very brief answer. 0.8. What is the ratio of the Value added (in %) in Colombia in 1987 to that in 2001?
Offer a very short reply. 1.32. What is the ratio of the Value added (in %) in Denmark in 1987 to that in 2001?
Keep it short and to the point. 2.21. What is the ratio of the Value added (in %) of Korea (Republic) in 1987 to that in 2001?
Your answer should be very brief. 2.1. What is the ratio of the Value added (in %) of Albania in 1988 to that in 1989?
Your response must be concise. 0.94. What is the ratio of the Value added (in %) in Colombia in 1988 to that in 1989?
Provide a succinct answer. 0.99. What is the ratio of the Value added (in %) in Denmark in 1988 to that in 1989?
Give a very brief answer. 1.09. What is the ratio of the Value added (in %) in Korea (Republic) in 1988 to that in 1989?
Ensure brevity in your answer.  1.09. What is the ratio of the Value added (in %) in Albania in 1988 to that in 1990?
Give a very brief answer. 0.79. What is the ratio of the Value added (in %) of Colombia in 1988 to that in 1990?
Keep it short and to the point. 0.97. What is the ratio of the Value added (in %) of Denmark in 1988 to that in 1990?
Provide a succinct answer. 1.14. What is the ratio of the Value added (in %) in Korea (Republic) in 1988 to that in 1990?
Your answer should be compact. 1.11. What is the ratio of the Value added (in %) of Albania in 1988 to that in 2000?
Provide a succinct answer. 0.97. What is the ratio of the Value added (in %) of Colombia in 1988 to that in 2000?
Keep it short and to the point. 1.38. What is the ratio of the Value added (in %) in Denmark in 1988 to that in 2000?
Ensure brevity in your answer.  1.96. What is the ratio of the Value added (in %) of Korea (Republic) in 1988 to that in 2000?
Keep it short and to the point. 1.92. What is the ratio of the Value added (in %) of Albania in 1988 to that in 2001?
Keep it short and to the point. 0.84. What is the ratio of the Value added (in %) of Colombia in 1988 to that in 2001?
Provide a succinct answer. 1.42. What is the ratio of the Value added (in %) of Denmark in 1988 to that in 2001?
Your response must be concise. 2.09. What is the ratio of the Value added (in %) in Korea (Republic) in 1988 to that in 2001?
Give a very brief answer. 1.97. What is the ratio of the Value added (in %) of Albania in 1989 to that in 1990?
Ensure brevity in your answer.  0.84. What is the ratio of the Value added (in %) in Colombia in 1989 to that in 1990?
Make the answer very short. 0.98. What is the ratio of the Value added (in %) in Denmark in 1989 to that in 1990?
Make the answer very short. 1.05. What is the ratio of the Value added (in %) in Korea (Republic) in 1989 to that in 1990?
Give a very brief answer. 1.02. What is the ratio of the Value added (in %) of Albania in 1989 to that in 2000?
Offer a very short reply. 1.04. What is the ratio of the Value added (in %) of Colombia in 1989 to that in 2000?
Provide a short and direct response. 1.39. What is the ratio of the Value added (in %) of Denmark in 1989 to that in 2000?
Make the answer very short. 1.8. What is the ratio of the Value added (in %) of Korea (Republic) in 1989 to that in 2000?
Keep it short and to the point. 1.75. What is the ratio of the Value added (in %) in Albania in 1989 to that in 2001?
Your response must be concise. 0.9. What is the ratio of the Value added (in %) in Colombia in 1989 to that in 2001?
Your answer should be compact. 1.44. What is the ratio of the Value added (in %) of Denmark in 1989 to that in 2001?
Make the answer very short. 1.92. What is the ratio of the Value added (in %) in Korea (Republic) in 1989 to that in 2001?
Ensure brevity in your answer.  1.8. What is the ratio of the Value added (in %) in Albania in 1990 to that in 2000?
Make the answer very short. 1.23. What is the ratio of the Value added (in %) of Colombia in 1990 to that in 2000?
Your answer should be very brief. 1.42. What is the ratio of the Value added (in %) of Denmark in 1990 to that in 2000?
Give a very brief answer. 1.72. What is the ratio of the Value added (in %) in Korea (Republic) in 1990 to that in 2000?
Make the answer very short. 1.73. What is the ratio of the Value added (in %) in Albania in 1990 to that in 2001?
Offer a terse response. 1.07. What is the ratio of the Value added (in %) of Colombia in 1990 to that in 2001?
Your answer should be compact. 1.46. What is the ratio of the Value added (in %) of Denmark in 1990 to that in 2001?
Provide a succinct answer. 1.83. What is the ratio of the Value added (in %) in Korea (Republic) in 1990 to that in 2001?
Give a very brief answer. 1.77. What is the ratio of the Value added (in %) in Albania in 2000 to that in 2001?
Your answer should be very brief. 0.87. What is the ratio of the Value added (in %) of Colombia in 2000 to that in 2001?
Your response must be concise. 1.03. What is the ratio of the Value added (in %) of Denmark in 2000 to that in 2001?
Provide a succinct answer. 1.06. What is the ratio of the Value added (in %) in Korea (Republic) in 2000 to that in 2001?
Offer a very short reply. 1.02. What is the difference between the highest and the second highest Value added (in %) in Albania?
Offer a very short reply. 2.12. What is the difference between the highest and the second highest Value added (in %) of Colombia?
Make the answer very short. 0.27. What is the difference between the highest and the second highest Value added (in %) of Denmark?
Offer a very short reply. 0.19. What is the difference between the highest and the second highest Value added (in %) in Korea (Republic)?
Ensure brevity in your answer.  0.24. What is the difference between the highest and the lowest Value added (in %) in Albania?
Offer a very short reply. 8.33. What is the difference between the highest and the lowest Value added (in %) of Colombia?
Make the answer very short. 4.84. What is the difference between the highest and the lowest Value added (in %) in Denmark?
Provide a short and direct response. 2.96. What is the difference between the highest and the lowest Value added (in %) in Korea (Republic)?
Your answer should be compact. 8.85. 